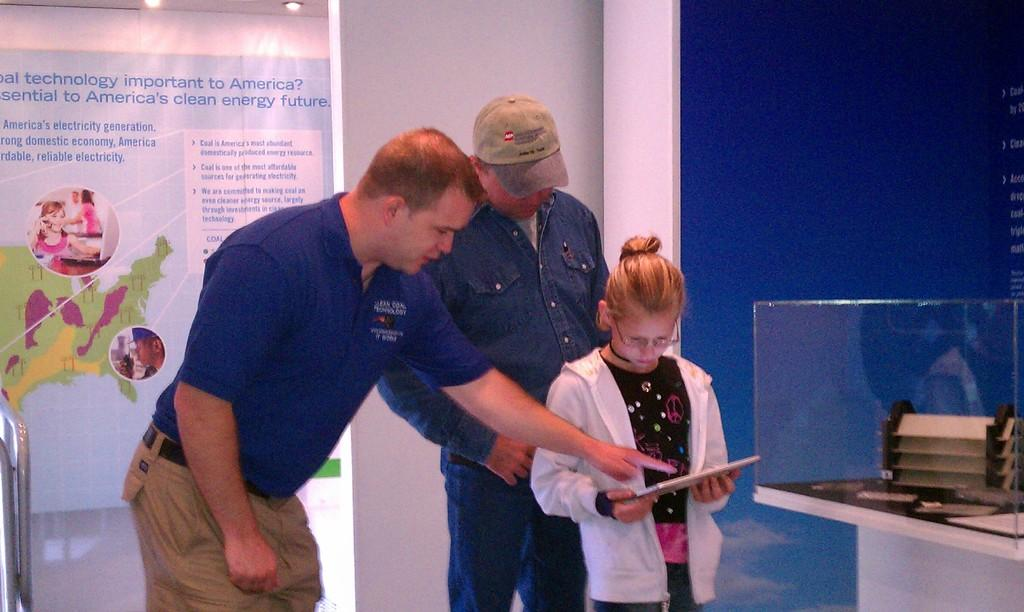<image>
Present a compact description of the photo's key features. A man wearing a blue shirt with "coal technology" on the upper left side, points to a book a girl is reading.. 